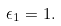Convert formula to latex. <formula><loc_0><loc_0><loc_500><loc_500>\epsilon _ { 1 } = 1 .</formula> 